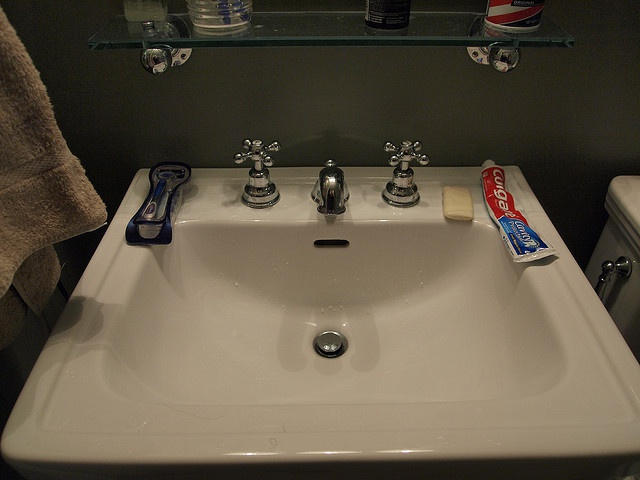Describe the objects in this image and their specific colors. I can see sink in black, gray, and tan tones, toilet in black and gray tones, and bottle in black, maroon, and gray tones in this image. 